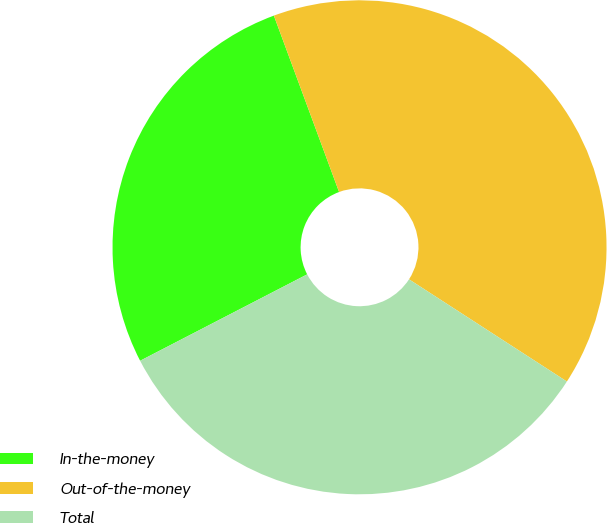Convert chart. <chart><loc_0><loc_0><loc_500><loc_500><pie_chart><fcel>In-the-money<fcel>Out-of-the-money<fcel>Total<nl><fcel>26.96%<fcel>39.78%<fcel>33.26%<nl></chart> 